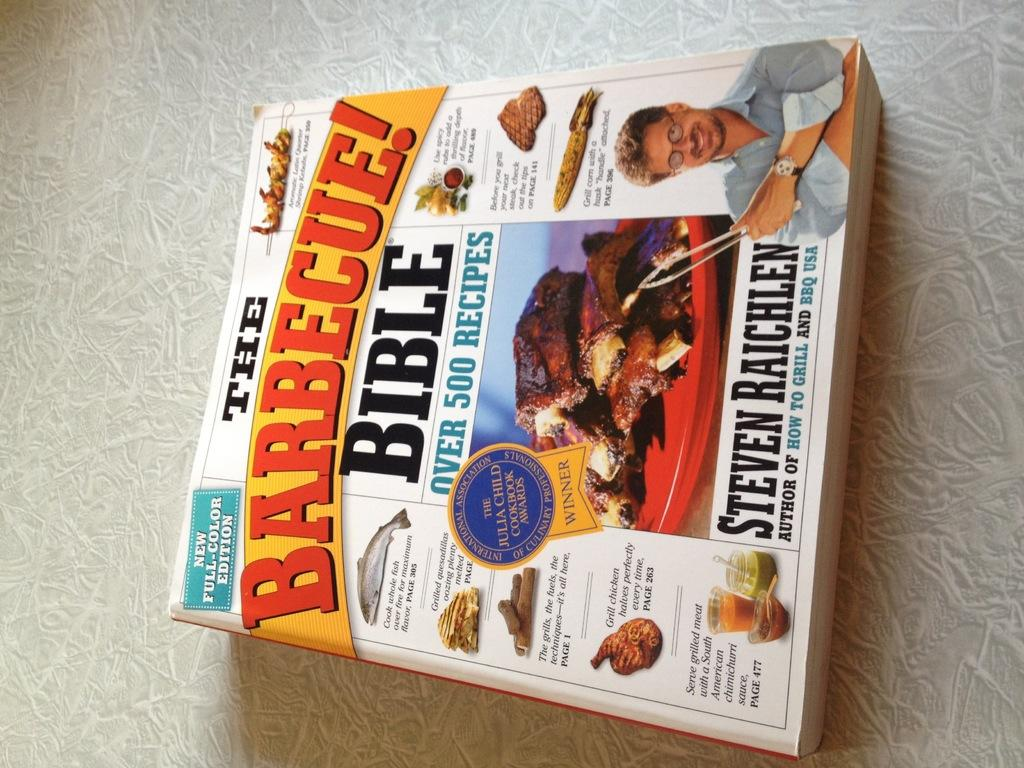<image>
Create a compact narrative representing the image presented. A book called The Barbecue Bible by Steven Raichlen. 